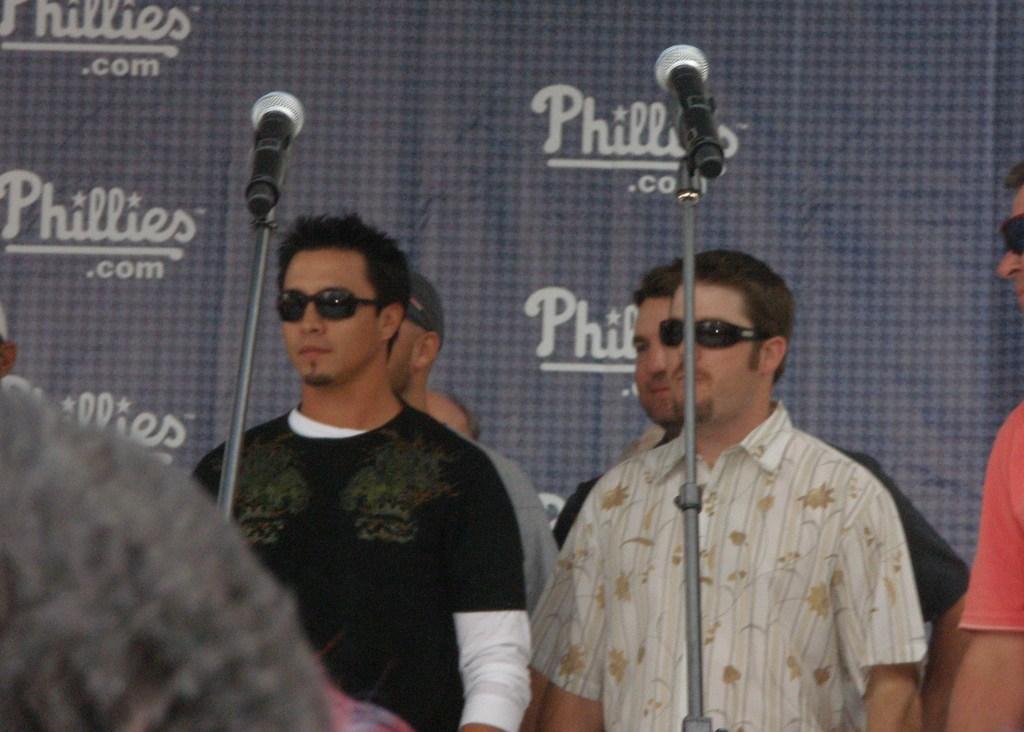Can you describe this image briefly? In the picture there are people present, in front of them there are poles with the microphones present, behind them there is a banner with the text. 